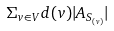<formula> <loc_0><loc_0><loc_500><loc_500>\Sigma _ { v \in V } d ( v ) | A _ { S _ { ( v ) } } |</formula> 